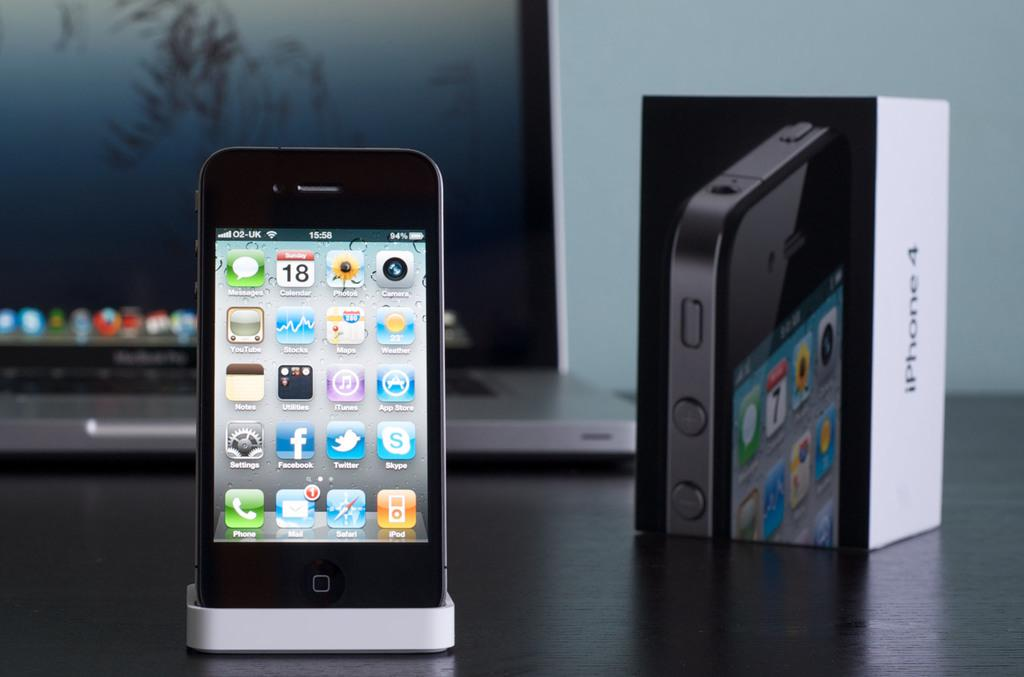Provide a one-sentence caption for the provided image. Iphone 4 is sitting on a port with a laptop and iphone box behind it. 